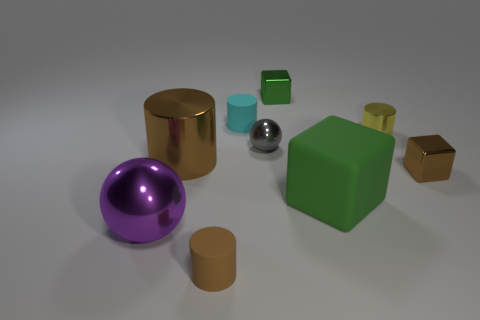The thing that is the same color as the large cube is what shape?
Ensure brevity in your answer.  Cube. There is a sphere that is the same size as the cyan cylinder; what is its color?
Make the answer very short. Gray. What color is the tiny metal object that is in front of the brown cylinder behind the tiny brown object that is in front of the big green thing?
Your response must be concise. Brown. There is a purple object; does it have the same size as the rubber cylinder behind the large purple sphere?
Offer a very short reply. No. What number of things are tiny shiny cylinders or green things?
Make the answer very short. 3. Is there a tiny gray block that has the same material as the small green object?
Provide a short and direct response. No. There is another cube that is the same color as the big cube; what size is it?
Offer a terse response. Small. What color is the tiny block that is in front of the green metal thing behind the small gray sphere?
Provide a short and direct response. Brown. Is the brown shiny block the same size as the cyan cylinder?
Offer a very short reply. Yes. How many spheres are yellow shiny objects or big purple metallic objects?
Provide a short and direct response. 1. 